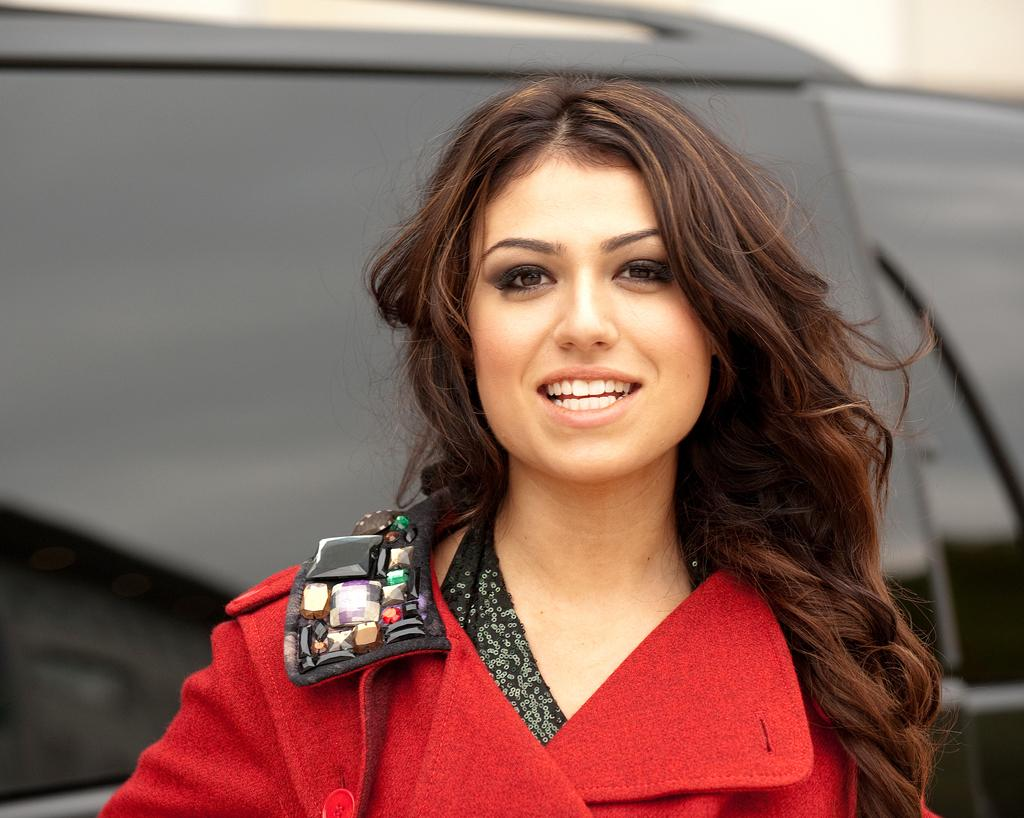Who is the main subject in the image? There is a woman in the image. What is the woman doing in the image? The woman is posing for a photo. How does the woman appear in the image? The woman is smiling in the image. What can be seen in the background of the image? There is an object in the background that resembles a vehicle. What type of force is being applied to the woman in the image? There is no force being applied to the woman in the image; she is posing for a photo. How does the woman's presence in the image reflect the values of society? The image does not provide enough context to determine how the woman's presence reflects the values of society. 